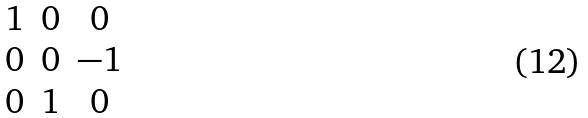Convert formula to latex. <formula><loc_0><loc_0><loc_500><loc_500>\begin{matrix} 1 & 0 & 0 \\ 0 & 0 & - 1 \\ 0 & 1 & 0 \\ \end{matrix}</formula> 